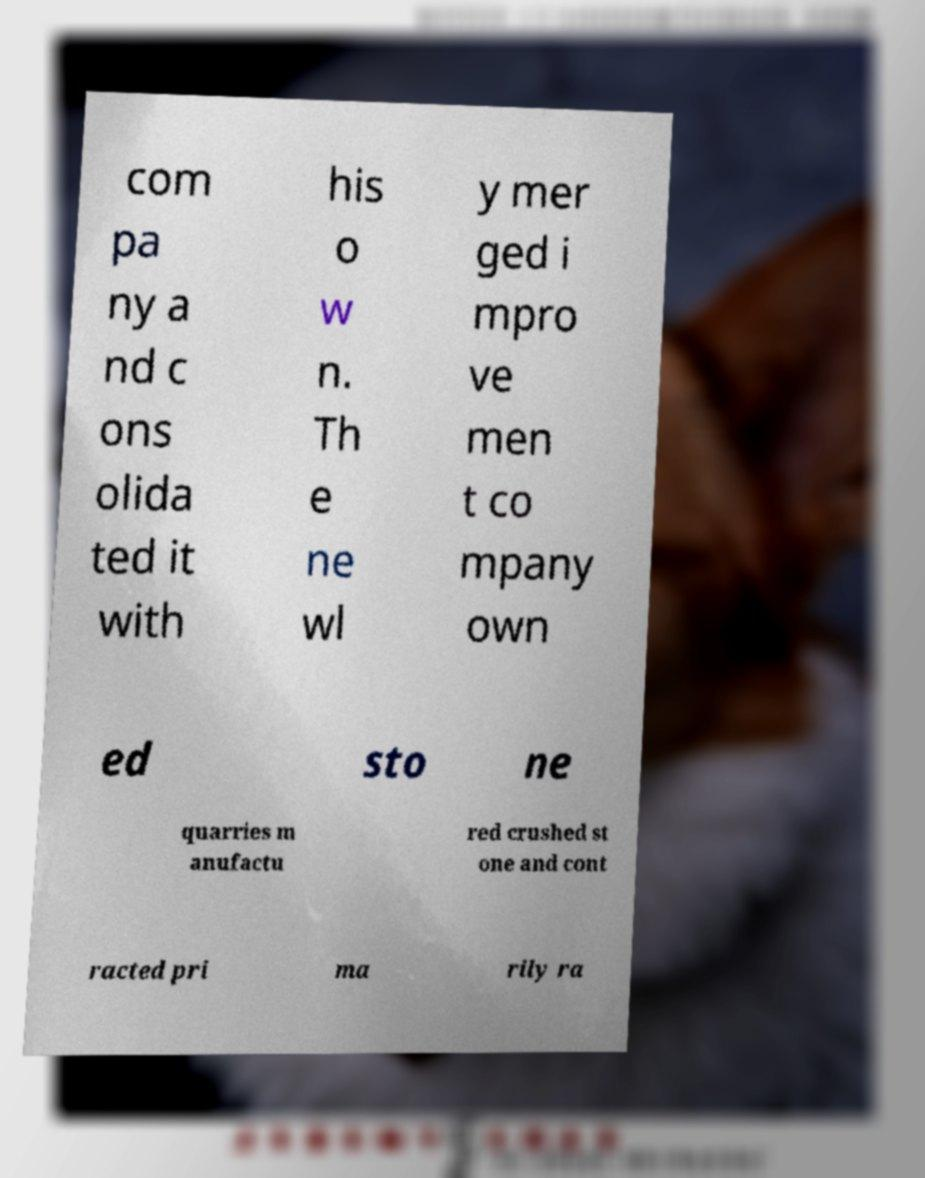Can you read and provide the text displayed in the image?This photo seems to have some interesting text. Can you extract and type it out for me? com pa ny a nd c ons olida ted it with his o w n. Th e ne wl y mer ged i mpro ve men t co mpany own ed sto ne quarries m anufactu red crushed st one and cont racted pri ma rily ra 